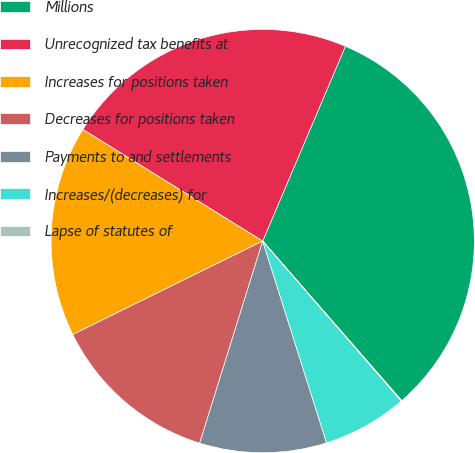Convert chart. <chart><loc_0><loc_0><loc_500><loc_500><pie_chart><fcel>Millions<fcel>Unrecognized tax benefits at<fcel>Increases for positions taken<fcel>Decreases for positions taken<fcel>Payments to and settlements<fcel>Increases/(decreases) for<fcel>Lapse of statutes of<nl><fcel>32.2%<fcel>22.55%<fcel>16.12%<fcel>12.91%<fcel>9.69%<fcel>6.48%<fcel>0.05%<nl></chart> 